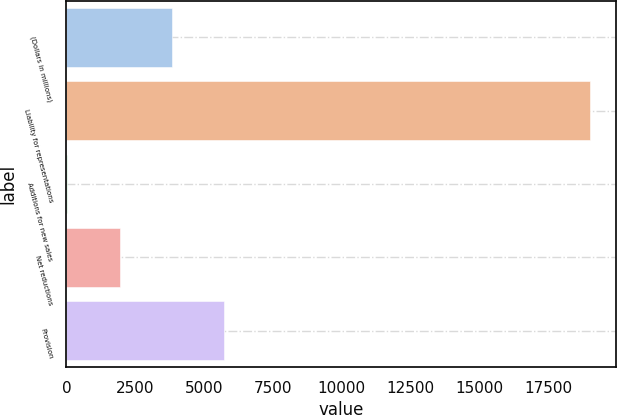<chart> <loc_0><loc_0><loc_500><loc_500><bar_chart><fcel>(Dollars in millions)<fcel>Liability for representations<fcel>Additions for new sales<fcel>Net reductions<fcel>Provision<nl><fcel>3826.6<fcel>19021<fcel>28<fcel>1927.3<fcel>5725.9<nl></chart> 